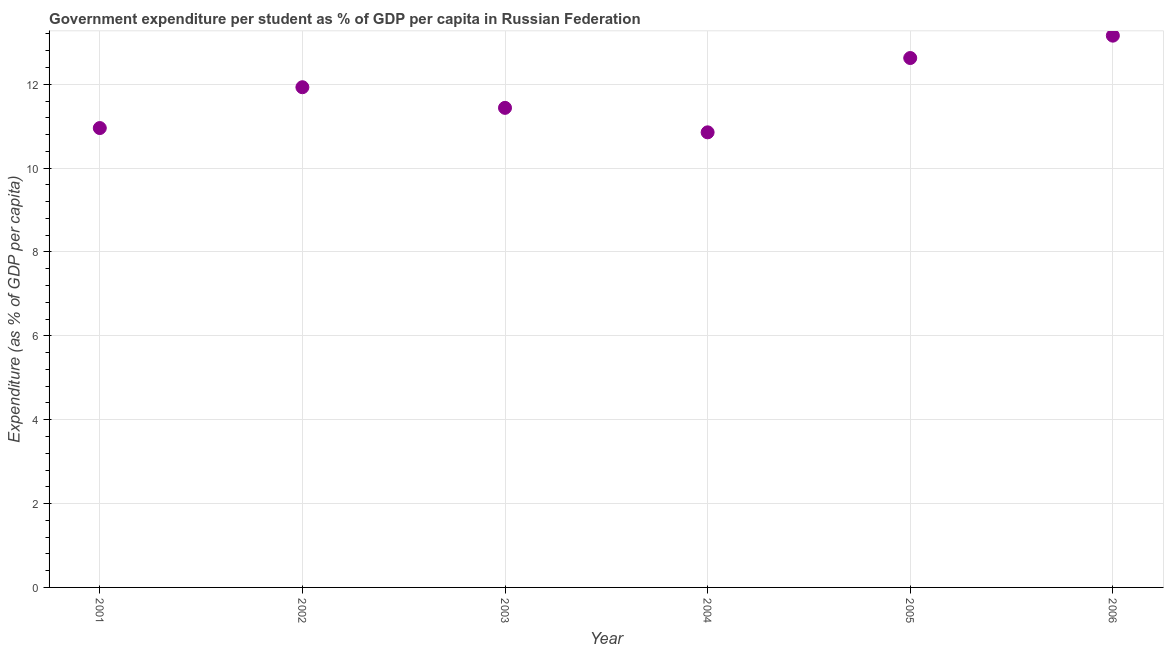What is the government expenditure per student in 2004?
Ensure brevity in your answer.  10.85. Across all years, what is the maximum government expenditure per student?
Your response must be concise. 13.16. Across all years, what is the minimum government expenditure per student?
Your answer should be very brief. 10.85. What is the sum of the government expenditure per student?
Offer a terse response. 70.96. What is the difference between the government expenditure per student in 2003 and 2004?
Your answer should be very brief. 0.58. What is the average government expenditure per student per year?
Keep it short and to the point. 11.83. What is the median government expenditure per student?
Provide a short and direct response. 11.68. In how many years, is the government expenditure per student greater than 12.4 %?
Provide a succinct answer. 2. Do a majority of the years between 2003 and 2006 (inclusive) have government expenditure per student greater than 0.4 %?
Offer a very short reply. Yes. What is the ratio of the government expenditure per student in 2002 to that in 2006?
Keep it short and to the point. 0.91. Is the difference between the government expenditure per student in 2004 and 2005 greater than the difference between any two years?
Make the answer very short. No. What is the difference between the highest and the second highest government expenditure per student?
Offer a terse response. 0.53. Is the sum of the government expenditure per student in 2001 and 2003 greater than the maximum government expenditure per student across all years?
Provide a short and direct response. Yes. What is the difference between the highest and the lowest government expenditure per student?
Offer a terse response. 2.31. How many dotlines are there?
Provide a succinct answer. 1. How many years are there in the graph?
Your response must be concise. 6. What is the difference between two consecutive major ticks on the Y-axis?
Give a very brief answer. 2. Does the graph contain any zero values?
Make the answer very short. No. Does the graph contain grids?
Offer a terse response. Yes. What is the title of the graph?
Your answer should be very brief. Government expenditure per student as % of GDP per capita in Russian Federation. What is the label or title of the X-axis?
Ensure brevity in your answer.  Year. What is the label or title of the Y-axis?
Make the answer very short. Expenditure (as % of GDP per capita). What is the Expenditure (as % of GDP per capita) in 2001?
Ensure brevity in your answer.  10.95. What is the Expenditure (as % of GDP per capita) in 2002?
Ensure brevity in your answer.  11.93. What is the Expenditure (as % of GDP per capita) in 2003?
Keep it short and to the point. 11.44. What is the Expenditure (as % of GDP per capita) in 2004?
Make the answer very short. 10.85. What is the Expenditure (as % of GDP per capita) in 2005?
Make the answer very short. 12.63. What is the Expenditure (as % of GDP per capita) in 2006?
Your response must be concise. 13.16. What is the difference between the Expenditure (as % of GDP per capita) in 2001 and 2002?
Your answer should be very brief. -0.97. What is the difference between the Expenditure (as % of GDP per capita) in 2001 and 2003?
Offer a very short reply. -0.48. What is the difference between the Expenditure (as % of GDP per capita) in 2001 and 2004?
Give a very brief answer. 0.1. What is the difference between the Expenditure (as % of GDP per capita) in 2001 and 2005?
Offer a very short reply. -1.67. What is the difference between the Expenditure (as % of GDP per capita) in 2001 and 2006?
Your answer should be compact. -2.2. What is the difference between the Expenditure (as % of GDP per capita) in 2002 and 2003?
Provide a succinct answer. 0.49. What is the difference between the Expenditure (as % of GDP per capita) in 2002 and 2004?
Your answer should be very brief. 1.08. What is the difference between the Expenditure (as % of GDP per capita) in 2002 and 2005?
Your answer should be very brief. -0.7. What is the difference between the Expenditure (as % of GDP per capita) in 2002 and 2006?
Keep it short and to the point. -1.23. What is the difference between the Expenditure (as % of GDP per capita) in 2003 and 2004?
Provide a short and direct response. 0.58. What is the difference between the Expenditure (as % of GDP per capita) in 2003 and 2005?
Give a very brief answer. -1.19. What is the difference between the Expenditure (as % of GDP per capita) in 2003 and 2006?
Provide a short and direct response. -1.72. What is the difference between the Expenditure (as % of GDP per capita) in 2004 and 2005?
Provide a short and direct response. -1.77. What is the difference between the Expenditure (as % of GDP per capita) in 2004 and 2006?
Your answer should be very brief. -2.31. What is the difference between the Expenditure (as % of GDP per capita) in 2005 and 2006?
Offer a terse response. -0.53. What is the ratio of the Expenditure (as % of GDP per capita) in 2001 to that in 2002?
Your response must be concise. 0.92. What is the ratio of the Expenditure (as % of GDP per capita) in 2001 to that in 2003?
Your answer should be compact. 0.96. What is the ratio of the Expenditure (as % of GDP per capita) in 2001 to that in 2004?
Provide a short and direct response. 1.01. What is the ratio of the Expenditure (as % of GDP per capita) in 2001 to that in 2005?
Offer a terse response. 0.87. What is the ratio of the Expenditure (as % of GDP per capita) in 2001 to that in 2006?
Your answer should be very brief. 0.83. What is the ratio of the Expenditure (as % of GDP per capita) in 2002 to that in 2003?
Offer a very short reply. 1.04. What is the ratio of the Expenditure (as % of GDP per capita) in 2002 to that in 2004?
Provide a succinct answer. 1.1. What is the ratio of the Expenditure (as % of GDP per capita) in 2002 to that in 2005?
Give a very brief answer. 0.94. What is the ratio of the Expenditure (as % of GDP per capita) in 2002 to that in 2006?
Your response must be concise. 0.91. What is the ratio of the Expenditure (as % of GDP per capita) in 2003 to that in 2004?
Provide a short and direct response. 1.05. What is the ratio of the Expenditure (as % of GDP per capita) in 2003 to that in 2005?
Make the answer very short. 0.91. What is the ratio of the Expenditure (as % of GDP per capita) in 2003 to that in 2006?
Offer a very short reply. 0.87. What is the ratio of the Expenditure (as % of GDP per capita) in 2004 to that in 2005?
Keep it short and to the point. 0.86. What is the ratio of the Expenditure (as % of GDP per capita) in 2004 to that in 2006?
Your answer should be very brief. 0.82. What is the ratio of the Expenditure (as % of GDP per capita) in 2005 to that in 2006?
Provide a short and direct response. 0.96. 